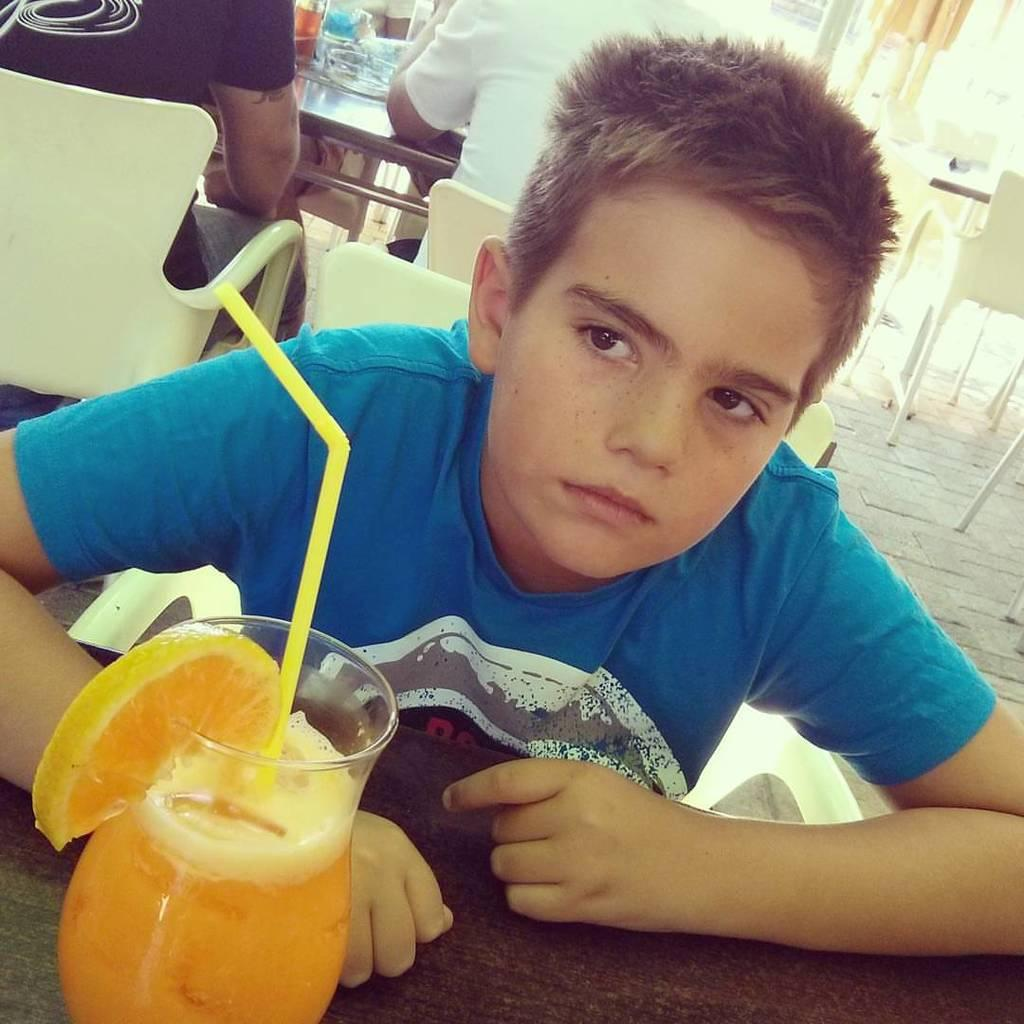Who is the main subject in the image? There is a boy in the image. What is the boy doing in the image? The boy is sitting in front of a juice glass. Where is the juice glass placed? The juice glass is on a table. Are there any other people in the image? Yes, there are two persons sitting on chairs at the back side of the image. What color is the boy's eye in the image? The provided facts do not mention the color of the boy's eye, so it cannot be determined from the image. 